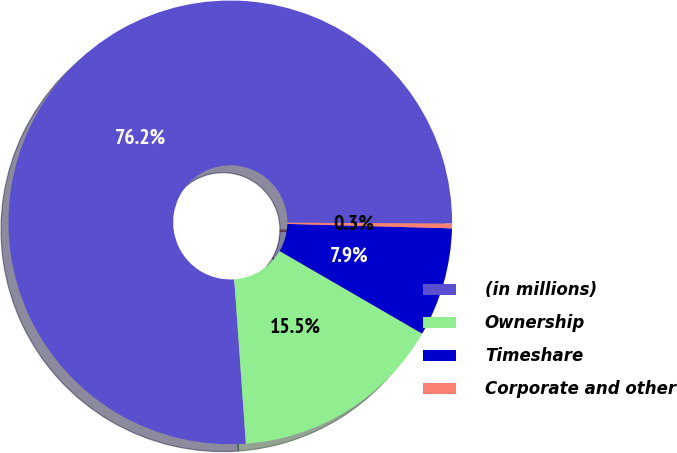Convert chart to OTSL. <chart><loc_0><loc_0><loc_500><loc_500><pie_chart><fcel>(in millions)<fcel>Ownership<fcel>Timeshare<fcel>Corporate and other<nl><fcel>76.21%<fcel>15.52%<fcel>7.93%<fcel>0.34%<nl></chart> 